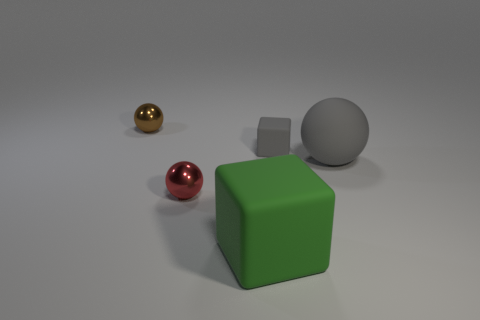Subtract all tiny shiny balls. How many balls are left? 1 Add 2 spheres. How many objects exist? 7 Subtract 1 blocks. How many blocks are left? 1 Subtract all brown spheres. How many spheres are left? 2 Subtract all spheres. How many objects are left? 2 Add 4 small red spheres. How many small red spheres are left? 5 Add 4 blue objects. How many blue objects exist? 4 Subtract 1 gray spheres. How many objects are left? 4 Subtract all purple balls. Subtract all gray cylinders. How many balls are left? 3 Subtract all yellow metallic balls. Subtract all big spheres. How many objects are left? 4 